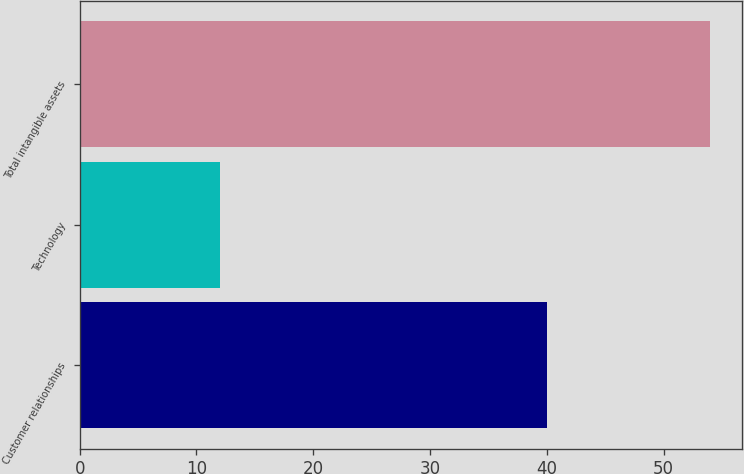Convert chart to OTSL. <chart><loc_0><loc_0><loc_500><loc_500><bar_chart><fcel>Customer relationships<fcel>Technology<fcel>Total intangible assets<nl><fcel>40<fcel>12<fcel>54<nl></chart> 